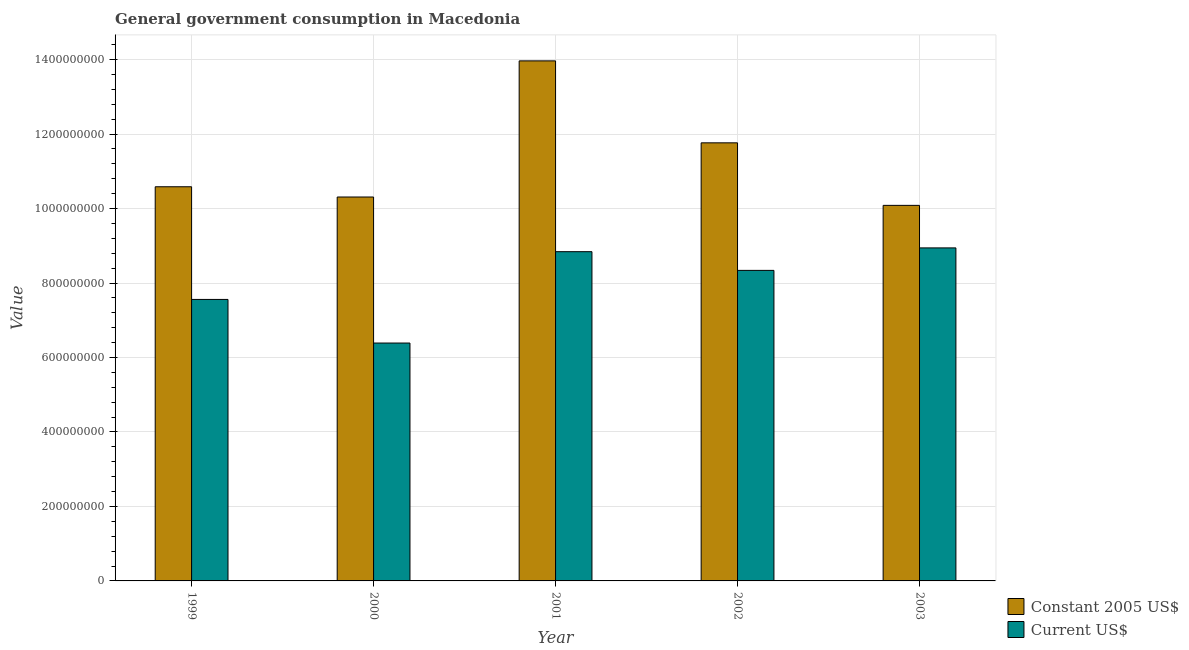Are the number of bars per tick equal to the number of legend labels?
Keep it short and to the point. Yes. How many bars are there on the 1st tick from the left?
Offer a very short reply. 2. In how many cases, is the number of bars for a given year not equal to the number of legend labels?
Your answer should be compact. 0. What is the value consumed in constant 2005 us$ in 2002?
Make the answer very short. 1.18e+09. Across all years, what is the maximum value consumed in constant 2005 us$?
Make the answer very short. 1.40e+09. Across all years, what is the minimum value consumed in current us$?
Provide a succinct answer. 6.39e+08. What is the total value consumed in current us$ in the graph?
Give a very brief answer. 4.01e+09. What is the difference between the value consumed in current us$ in 1999 and that in 2002?
Your answer should be very brief. -7.80e+07. What is the difference between the value consumed in current us$ in 2003 and the value consumed in constant 2005 us$ in 2001?
Your answer should be compact. 1.02e+07. What is the average value consumed in constant 2005 us$ per year?
Give a very brief answer. 1.13e+09. What is the ratio of the value consumed in current us$ in 2002 to that in 2003?
Your answer should be compact. 0.93. Is the difference between the value consumed in current us$ in 2001 and 2002 greater than the difference between the value consumed in constant 2005 us$ in 2001 and 2002?
Keep it short and to the point. No. What is the difference between the highest and the second highest value consumed in current us$?
Your response must be concise. 1.02e+07. What is the difference between the highest and the lowest value consumed in current us$?
Your answer should be very brief. 2.55e+08. In how many years, is the value consumed in constant 2005 us$ greater than the average value consumed in constant 2005 us$ taken over all years?
Offer a very short reply. 2. What does the 1st bar from the left in 2003 represents?
Give a very brief answer. Constant 2005 US$. What does the 1st bar from the right in 2002 represents?
Your answer should be very brief. Current US$. Are all the bars in the graph horizontal?
Ensure brevity in your answer.  No. How many years are there in the graph?
Provide a succinct answer. 5. What is the difference between two consecutive major ticks on the Y-axis?
Keep it short and to the point. 2.00e+08. Are the values on the major ticks of Y-axis written in scientific E-notation?
Offer a very short reply. No. Does the graph contain any zero values?
Keep it short and to the point. No. How many legend labels are there?
Your answer should be very brief. 2. What is the title of the graph?
Keep it short and to the point. General government consumption in Macedonia. Does "Exports" appear as one of the legend labels in the graph?
Keep it short and to the point. No. What is the label or title of the Y-axis?
Offer a very short reply. Value. What is the Value of Constant 2005 US$ in 1999?
Provide a short and direct response. 1.06e+09. What is the Value in Current US$ in 1999?
Your answer should be very brief. 7.56e+08. What is the Value of Constant 2005 US$ in 2000?
Ensure brevity in your answer.  1.03e+09. What is the Value of Current US$ in 2000?
Your response must be concise. 6.39e+08. What is the Value in Constant 2005 US$ in 2001?
Your answer should be very brief. 1.40e+09. What is the Value in Current US$ in 2001?
Keep it short and to the point. 8.84e+08. What is the Value of Constant 2005 US$ in 2002?
Give a very brief answer. 1.18e+09. What is the Value of Current US$ in 2002?
Keep it short and to the point. 8.34e+08. What is the Value of Constant 2005 US$ in 2003?
Provide a succinct answer. 1.01e+09. What is the Value in Current US$ in 2003?
Ensure brevity in your answer.  8.94e+08. Across all years, what is the maximum Value in Constant 2005 US$?
Provide a short and direct response. 1.40e+09. Across all years, what is the maximum Value in Current US$?
Offer a terse response. 8.94e+08. Across all years, what is the minimum Value in Constant 2005 US$?
Your response must be concise. 1.01e+09. Across all years, what is the minimum Value of Current US$?
Provide a short and direct response. 6.39e+08. What is the total Value in Constant 2005 US$ in the graph?
Offer a terse response. 5.67e+09. What is the total Value in Current US$ in the graph?
Offer a terse response. 4.01e+09. What is the difference between the Value in Constant 2005 US$ in 1999 and that in 2000?
Your response must be concise. 2.75e+07. What is the difference between the Value of Current US$ in 1999 and that in 2000?
Ensure brevity in your answer.  1.17e+08. What is the difference between the Value in Constant 2005 US$ in 1999 and that in 2001?
Your response must be concise. -3.38e+08. What is the difference between the Value of Current US$ in 1999 and that in 2001?
Ensure brevity in your answer.  -1.28e+08. What is the difference between the Value in Constant 2005 US$ in 1999 and that in 2002?
Your response must be concise. -1.18e+08. What is the difference between the Value in Current US$ in 1999 and that in 2002?
Your answer should be compact. -7.80e+07. What is the difference between the Value of Constant 2005 US$ in 1999 and that in 2003?
Make the answer very short. 4.99e+07. What is the difference between the Value of Current US$ in 1999 and that in 2003?
Keep it short and to the point. -1.38e+08. What is the difference between the Value of Constant 2005 US$ in 2000 and that in 2001?
Provide a short and direct response. -3.66e+08. What is the difference between the Value in Current US$ in 2000 and that in 2001?
Make the answer very short. -2.45e+08. What is the difference between the Value in Constant 2005 US$ in 2000 and that in 2002?
Offer a terse response. -1.45e+08. What is the difference between the Value of Current US$ in 2000 and that in 2002?
Ensure brevity in your answer.  -1.95e+08. What is the difference between the Value in Constant 2005 US$ in 2000 and that in 2003?
Offer a very short reply. 2.24e+07. What is the difference between the Value of Current US$ in 2000 and that in 2003?
Make the answer very short. -2.55e+08. What is the difference between the Value of Constant 2005 US$ in 2001 and that in 2002?
Your response must be concise. 2.20e+08. What is the difference between the Value of Current US$ in 2001 and that in 2002?
Provide a short and direct response. 5.02e+07. What is the difference between the Value of Constant 2005 US$ in 2001 and that in 2003?
Your response must be concise. 3.88e+08. What is the difference between the Value of Current US$ in 2001 and that in 2003?
Your answer should be compact. -1.02e+07. What is the difference between the Value of Constant 2005 US$ in 2002 and that in 2003?
Your answer should be compact. 1.68e+08. What is the difference between the Value in Current US$ in 2002 and that in 2003?
Provide a succinct answer. -6.04e+07. What is the difference between the Value of Constant 2005 US$ in 1999 and the Value of Current US$ in 2000?
Your answer should be very brief. 4.20e+08. What is the difference between the Value of Constant 2005 US$ in 1999 and the Value of Current US$ in 2001?
Provide a succinct answer. 1.74e+08. What is the difference between the Value in Constant 2005 US$ in 1999 and the Value in Current US$ in 2002?
Provide a short and direct response. 2.25e+08. What is the difference between the Value of Constant 2005 US$ in 1999 and the Value of Current US$ in 2003?
Provide a short and direct response. 1.64e+08. What is the difference between the Value in Constant 2005 US$ in 2000 and the Value in Current US$ in 2001?
Keep it short and to the point. 1.47e+08. What is the difference between the Value in Constant 2005 US$ in 2000 and the Value in Current US$ in 2002?
Provide a short and direct response. 1.97e+08. What is the difference between the Value of Constant 2005 US$ in 2000 and the Value of Current US$ in 2003?
Keep it short and to the point. 1.37e+08. What is the difference between the Value of Constant 2005 US$ in 2001 and the Value of Current US$ in 2002?
Offer a very short reply. 5.63e+08. What is the difference between the Value in Constant 2005 US$ in 2001 and the Value in Current US$ in 2003?
Your answer should be compact. 5.02e+08. What is the difference between the Value in Constant 2005 US$ in 2002 and the Value in Current US$ in 2003?
Your answer should be compact. 2.82e+08. What is the average Value of Constant 2005 US$ per year?
Give a very brief answer. 1.13e+09. What is the average Value of Current US$ per year?
Ensure brevity in your answer.  8.01e+08. In the year 1999, what is the difference between the Value of Constant 2005 US$ and Value of Current US$?
Your response must be concise. 3.03e+08. In the year 2000, what is the difference between the Value in Constant 2005 US$ and Value in Current US$?
Your response must be concise. 3.92e+08. In the year 2001, what is the difference between the Value of Constant 2005 US$ and Value of Current US$?
Ensure brevity in your answer.  5.12e+08. In the year 2002, what is the difference between the Value of Constant 2005 US$ and Value of Current US$?
Your response must be concise. 3.42e+08. In the year 2003, what is the difference between the Value of Constant 2005 US$ and Value of Current US$?
Your answer should be very brief. 1.14e+08. What is the ratio of the Value of Constant 2005 US$ in 1999 to that in 2000?
Provide a succinct answer. 1.03. What is the ratio of the Value of Current US$ in 1999 to that in 2000?
Make the answer very short. 1.18. What is the ratio of the Value in Constant 2005 US$ in 1999 to that in 2001?
Your response must be concise. 0.76. What is the ratio of the Value of Current US$ in 1999 to that in 2001?
Give a very brief answer. 0.85. What is the ratio of the Value in Constant 2005 US$ in 1999 to that in 2002?
Your response must be concise. 0.9. What is the ratio of the Value in Current US$ in 1999 to that in 2002?
Keep it short and to the point. 0.91. What is the ratio of the Value in Constant 2005 US$ in 1999 to that in 2003?
Give a very brief answer. 1.05. What is the ratio of the Value in Current US$ in 1999 to that in 2003?
Your answer should be compact. 0.85. What is the ratio of the Value of Constant 2005 US$ in 2000 to that in 2001?
Make the answer very short. 0.74. What is the ratio of the Value of Current US$ in 2000 to that in 2001?
Give a very brief answer. 0.72. What is the ratio of the Value in Constant 2005 US$ in 2000 to that in 2002?
Your answer should be very brief. 0.88. What is the ratio of the Value of Current US$ in 2000 to that in 2002?
Ensure brevity in your answer.  0.77. What is the ratio of the Value in Constant 2005 US$ in 2000 to that in 2003?
Provide a succinct answer. 1.02. What is the ratio of the Value in Current US$ in 2000 to that in 2003?
Offer a terse response. 0.71. What is the ratio of the Value in Constant 2005 US$ in 2001 to that in 2002?
Offer a terse response. 1.19. What is the ratio of the Value in Current US$ in 2001 to that in 2002?
Keep it short and to the point. 1.06. What is the ratio of the Value of Constant 2005 US$ in 2001 to that in 2003?
Provide a succinct answer. 1.38. What is the ratio of the Value in Current US$ in 2001 to that in 2003?
Your answer should be very brief. 0.99. What is the ratio of the Value in Constant 2005 US$ in 2002 to that in 2003?
Provide a short and direct response. 1.17. What is the ratio of the Value in Current US$ in 2002 to that in 2003?
Give a very brief answer. 0.93. What is the difference between the highest and the second highest Value in Constant 2005 US$?
Your answer should be compact. 2.20e+08. What is the difference between the highest and the second highest Value of Current US$?
Make the answer very short. 1.02e+07. What is the difference between the highest and the lowest Value in Constant 2005 US$?
Offer a very short reply. 3.88e+08. What is the difference between the highest and the lowest Value in Current US$?
Keep it short and to the point. 2.55e+08. 